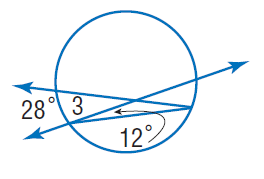Answer the mathemtical geometry problem and directly provide the correct option letter.
Question: Find the measure of m \angle 3. Assume that segments that appear tangent are tangent.
Choices: A: 12 B: 20 C: 26 D: 28 C 